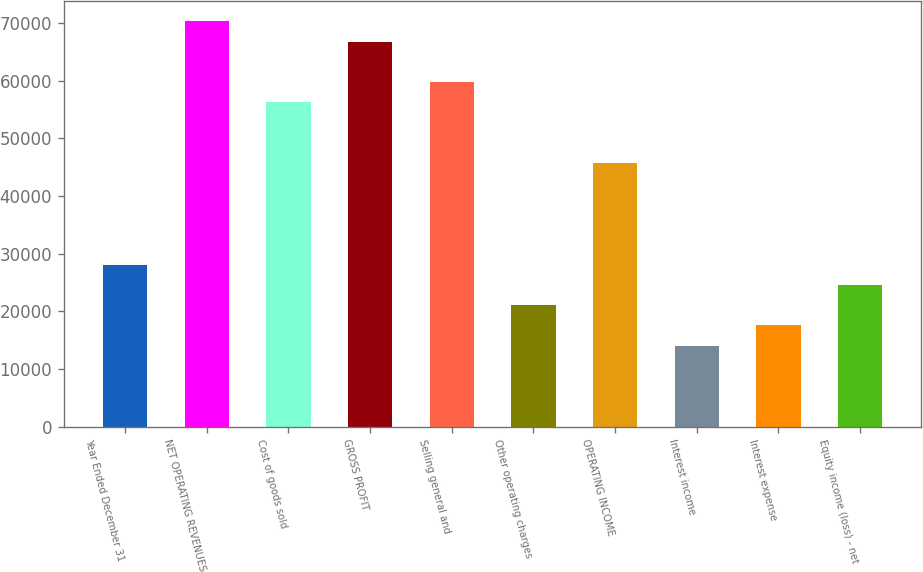Convert chart to OTSL. <chart><loc_0><loc_0><loc_500><loc_500><bar_chart><fcel>Year Ended December 31<fcel>NET OPERATING REVENUES<fcel>Cost of goods sold<fcel>GROSS PROFIT<fcel>Selling general and<fcel>Other operating charges<fcel>OPERATING INCOME<fcel>Interest income<fcel>Interest expense<fcel>Equity income (loss) - net<nl><fcel>28095.7<fcel>70235.5<fcel>56188.9<fcel>66723.9<fcel>59700.6<fcel>21072.4<fcel>45654<fcel>14049.1<fcel>17560.8<fcel>24584.1<nl></chart> 